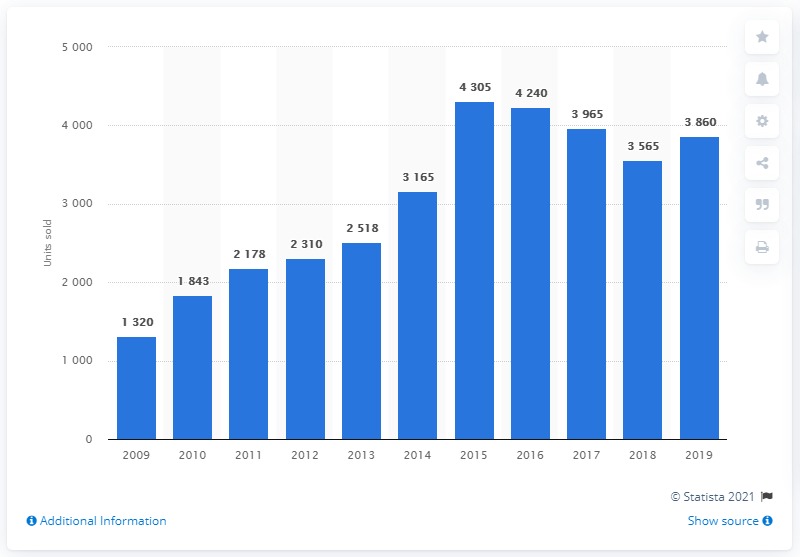Point out several critical features in this image. In the year 2009, Porsche sold the greatest number of cars in Switzerland. 